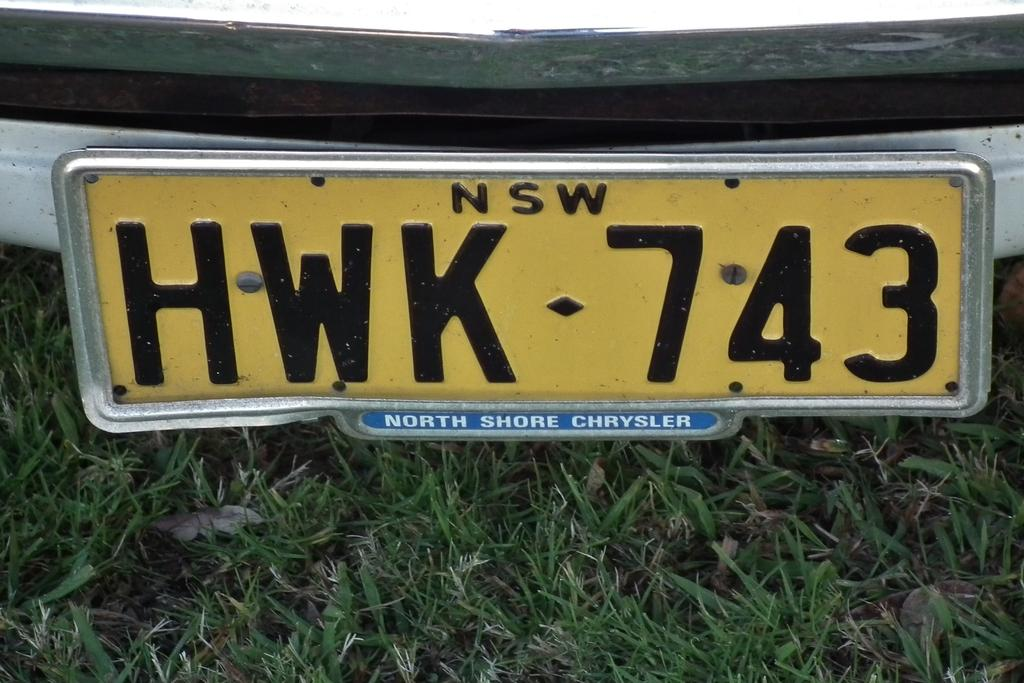Provide a one-sentence caption for the provided image. an image of car license plates for North Shore Chrysler. 